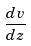<formula> <loc_0><loc_0><loc_500><loc_500>\frac { d v } { d z }</formula> 